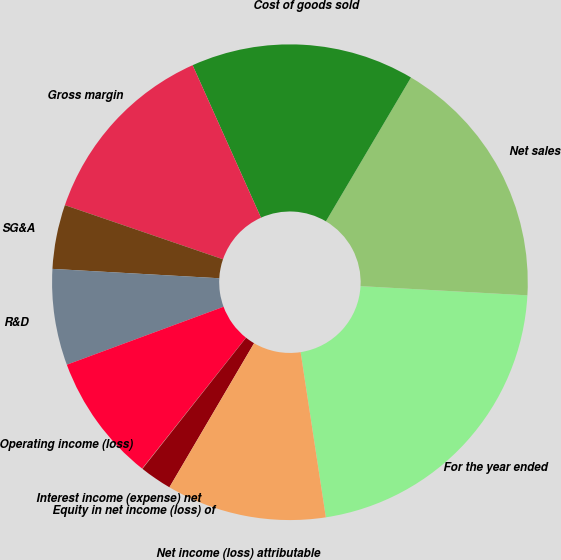Convert chart to OTSL. <chart><loc_0><loc_0><loc_500><loc_500><pie_chart><fcel>For the year ended<fcel>Net sales<fcel>Cost of goods sold<fcel>Gross margin<fcel>SG&A<fcel>R&D<fcel>Operating income (loss)<fcel>Interest income (expense) net<fcel>Equity in net income (loss) of<fcel>Net income (loss) attributable<nl><fcel>21.71%<fcel>17.38%<fcel>15.21%<fcel>13.04%<fcel>4.36%<fcel>6.53%<fcel>8.7%<fcel>0.02%<fcel>2.19%<fcel>10.87%<nl></chart> 